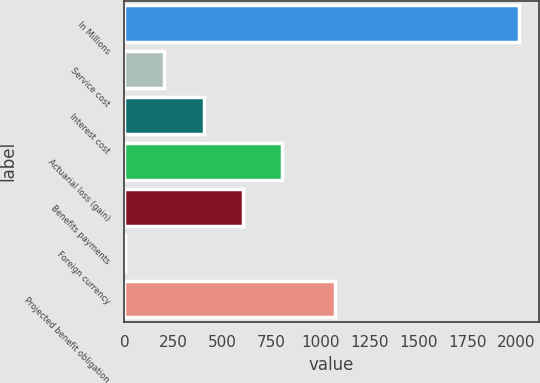<chart> <loc_0><loc_0><loc_500><loc_500><bar_chart><fcel>In Millions<fcel>Service cost<fcel>Interest cost<fcel>Actuarial loss (gain)<fcel>Benefits payments<fcel>Foreign currency<fcel>Projected benefit obligation<nl><fcel>2014<fcel>202.3<fcel>403.6<fcel>806.2<fcel>604.9<fcel>1<fcel>1074.8<nl></chart> 